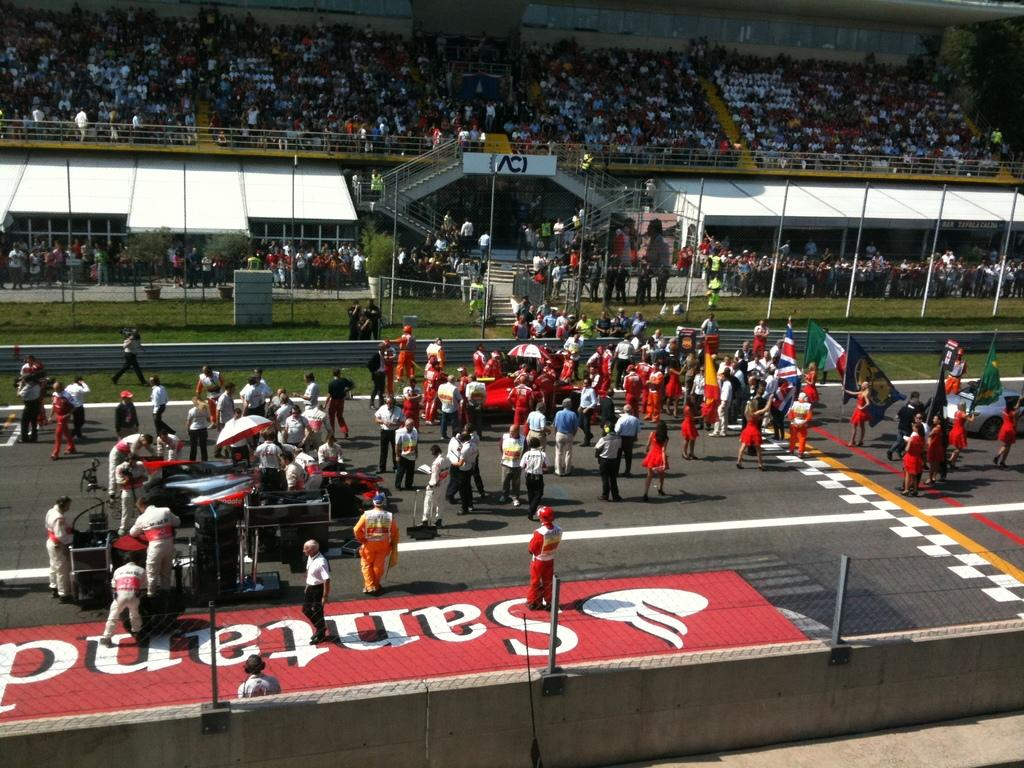<image>
Offer a succinct explanation of the picture presented. A crowd of people are gathered on a raceway track and the ground is painted to say Santand. 